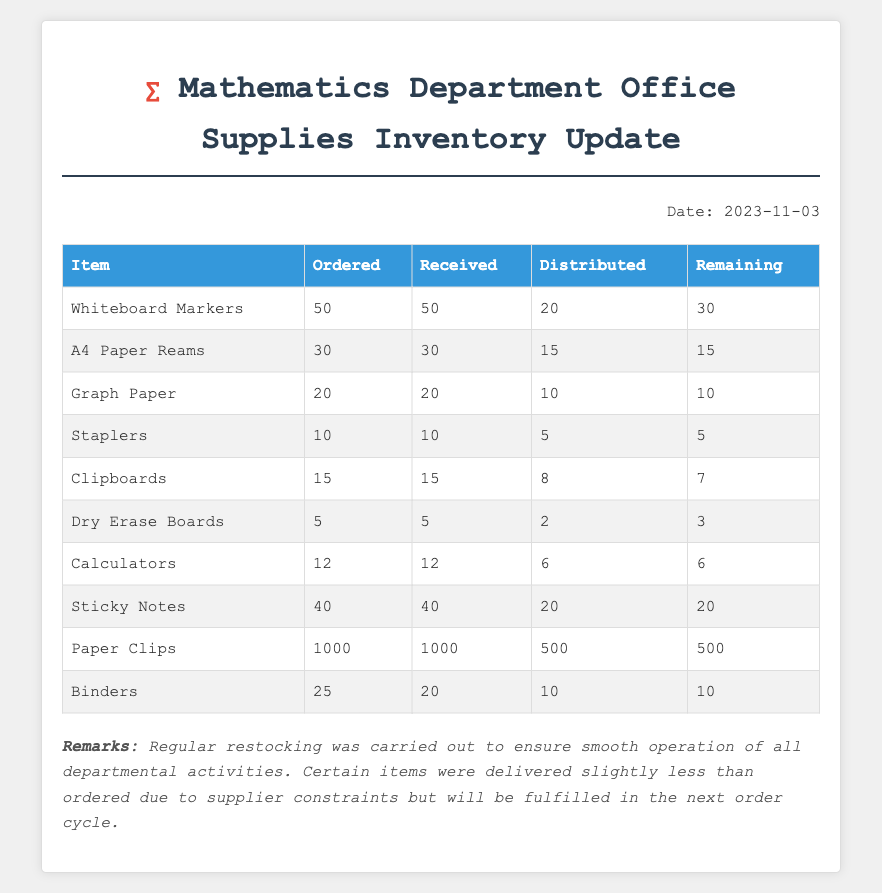What is the date of the inventory update? The date of the inventory update is provided at the top of the document as "Date: 2023-11-03".
Answer: 2023-11-03 How many Whiteboard Markers were ordered? The number of Whiteboard Markers ordered is listed in the table under the "Ordered" column for that item.
Answer: 50 How many items were distributed in total? To find the total distributed items, you would add up the distributed quantities for each item listed in the document.
Answer: 596 Which item has the highest quantity remaining? The remaining quantities in the table indicate which item has the highest amount left.
Answer: Paper Clips What percentage of A4 Paper Reams were distributed? To find the percentage distributed, calculate (15 distributed / 30 ordered) * 100.
Answer: 50% How many Binders were received? The received quantity of Binders is directly listed in the table under the "Received" column for that item.
Answer: 20 What is the total remaining quantity of Dry Erase Boards? The total remaining of Dry Erase Boards is provided in the table under the "Remaining" column for that item.
Answer: 3 What is mentioned in the remarks section? The remarks section summarizes the regular restocking and issues with certain item deliveries due to supplier constraints.
Answer: Regular restocking was carried out.. How many items were ordered in total? To find the total number of items ordered, one must sum the "Ordered" column across all items listed.
Answer: 292 